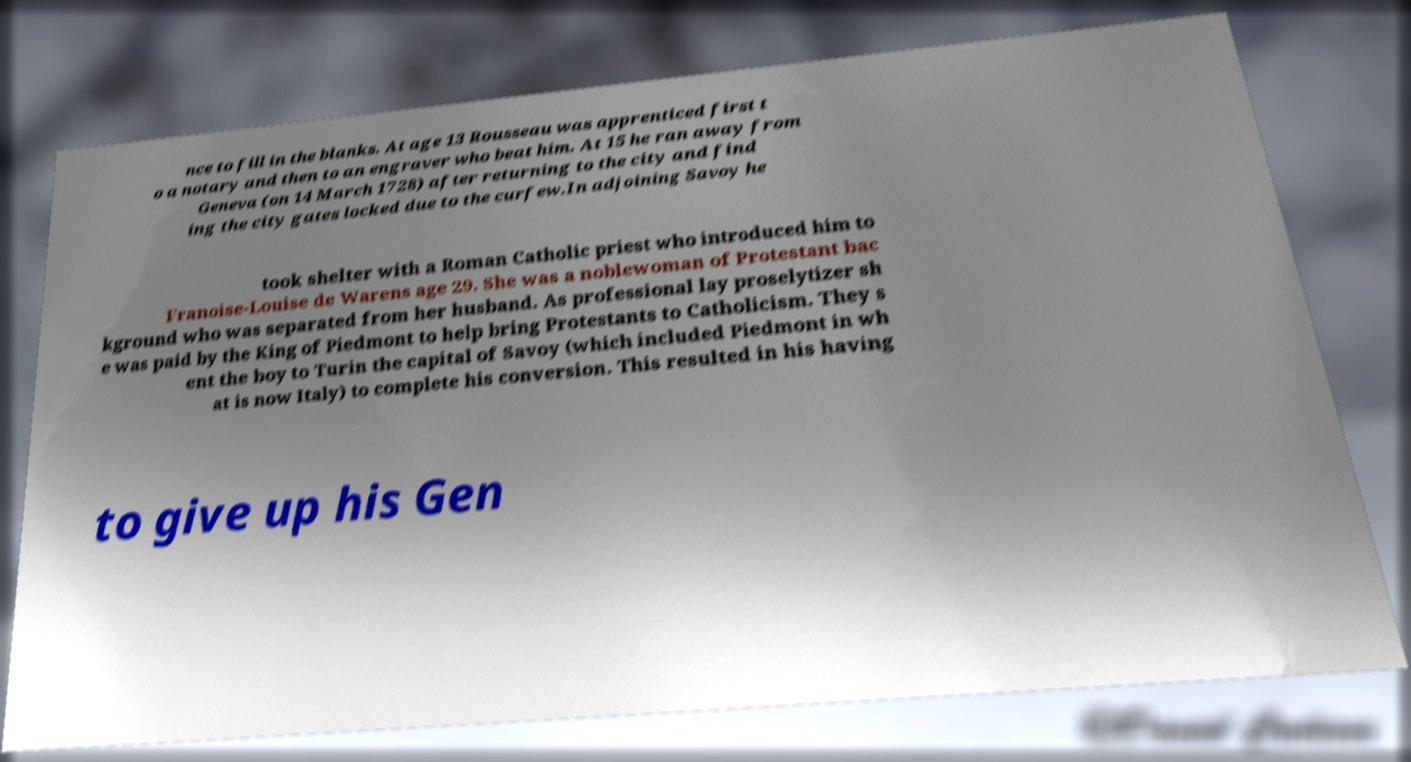Could you assist in decoding the text presented in this image and type it out clearly? nce to fill in the blanks. At age 13 Rousseau was apprenticed first t o a notary and then to an engraver who beat him. At 15 he ran away from Geneva (on 14 March 1728) after returning to the city and find ing the city gates locked due to the curfew.In adjoining Savoy he took shelter with a Roman Catholic priest who introduced him to Franoise-Louise de Warens age 29. She was a noblewoman of Protestant bac kground who was separated from her husband. As professional lay proselytizer sh e was paid by the King of Piedmont to help bring Protestants to Catholicism. They s ent the boy to Turin the capital of Savoy (which included Piedmont in wh at is now Italy) to complete his conversion. This resulted in his having to give up his Gen 